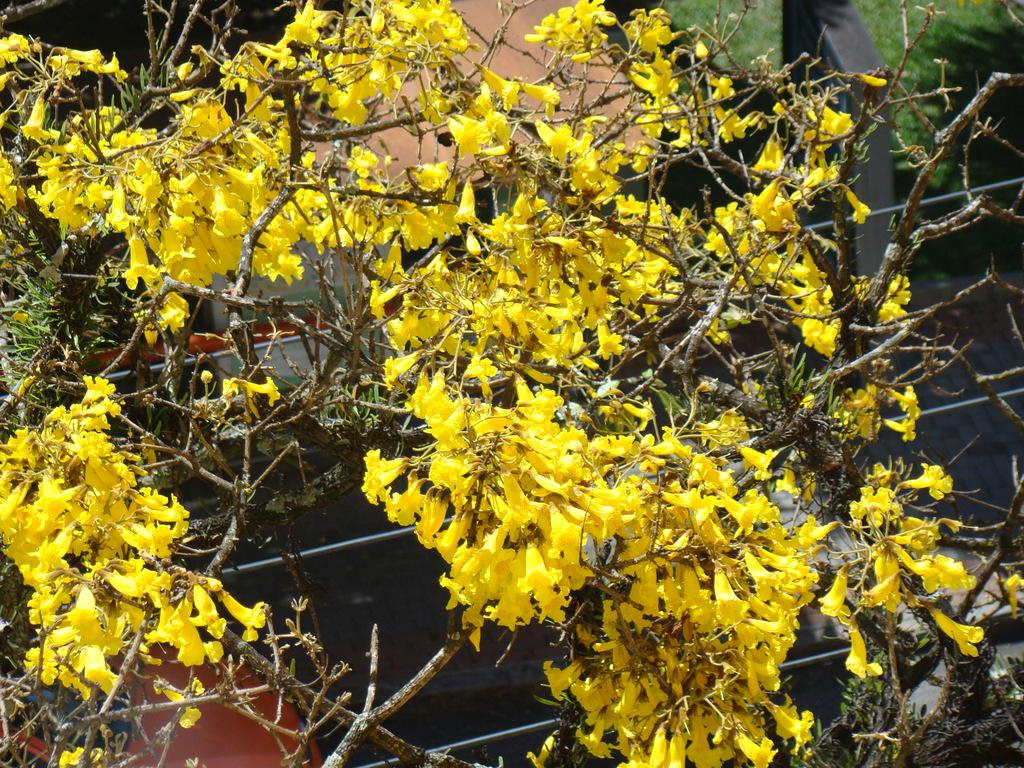What type of plants can be seen in the image? There are plants with flowers in the image. Can you describe the objects in the background of the image? Unfortunately, the provided facts do not give any information about the objects in the background. How many ducks are swimming in the water near the plants in the image? There is no water or ducks present in the image; it features plants with flowers. 